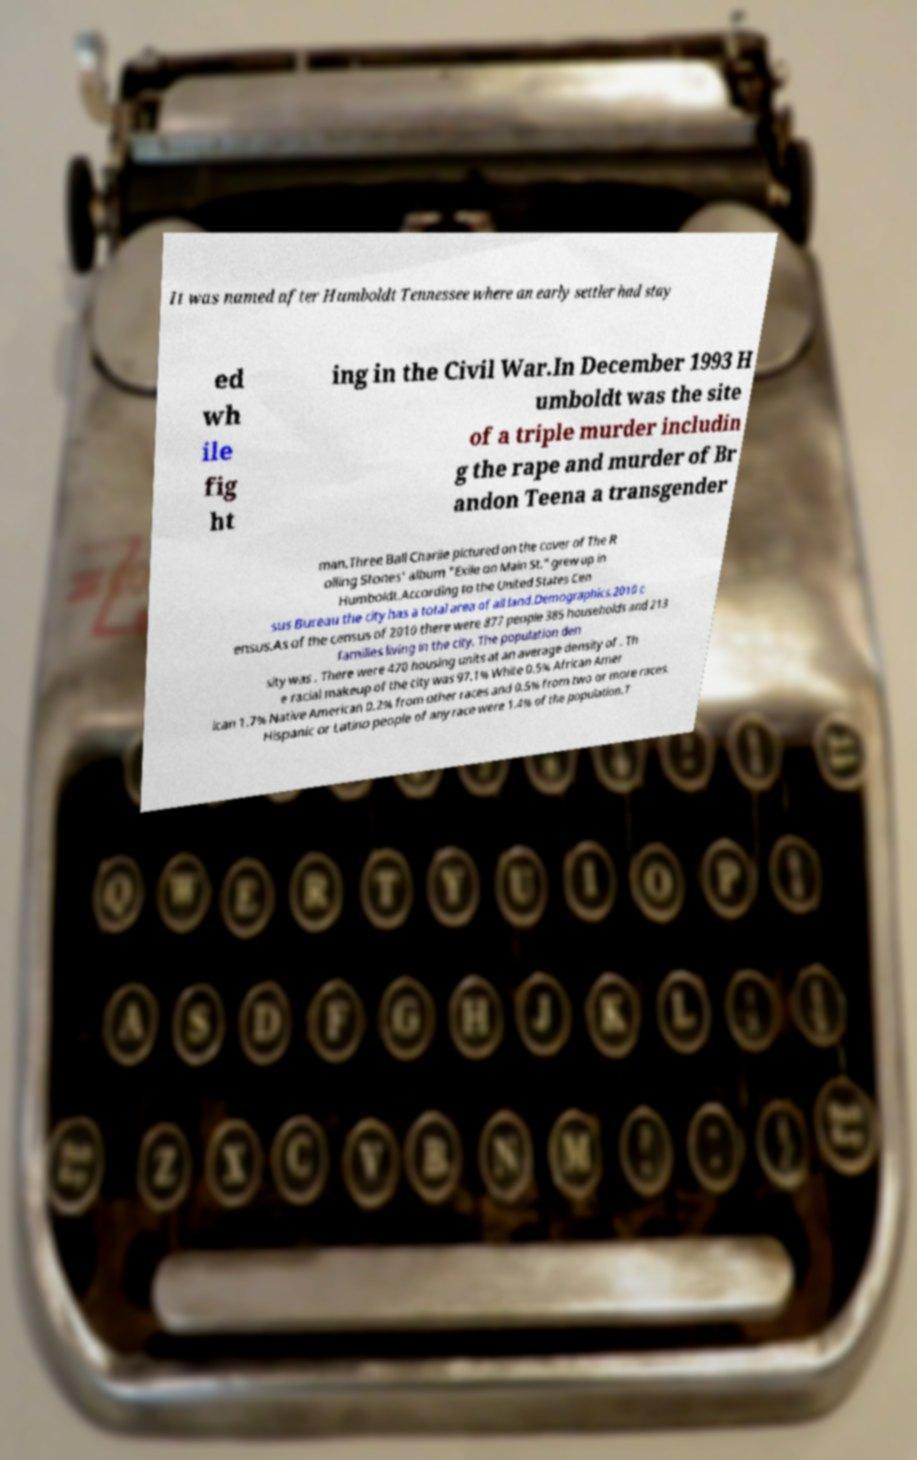I need the written content from this picture converted into text. Can you do that? It was named after Humboldt Tennessee where an early settler had stay ed wh ile fig ht ing in the Civil War.In December 1993 H umboldt was the site of a triple murder includin g the rape and murder of Br andon Teena a transgender man.Three Ball Charlie pictured on the cover of The R olling Stones' album "Exile on Main St." grew up in Humboldt.According to the United States Cen sus Bureau the city has a total area of all land.Demographics.2010 c ensus.As of the census of 2010 there were 877 people 385 households and 213 families living in the city. The population den sity was . There were 470 housing units at an average density of . Th e racial makeup of the city was 97.1% White 0.5% African Amer ican 1.7% Native American 0.2% from other races and 0.5% from two or more races. Hispanic or Latino people of any race were 1.4% of the population.T 